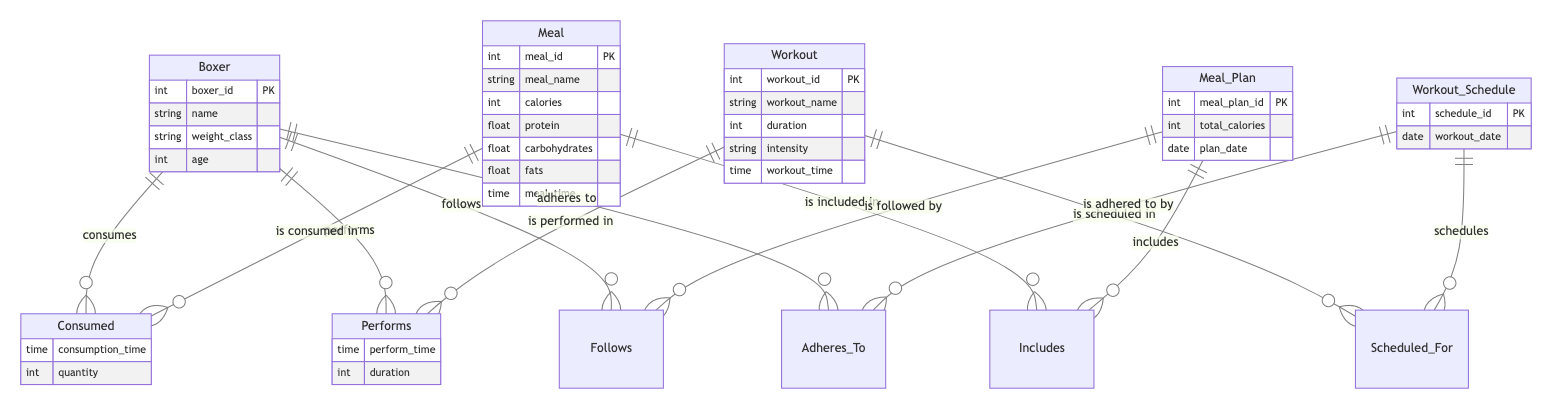What are the attributes of the Boxer entity? The Boxer entity includes the following attributes: boxer_id, name, weight_class, and age. These can be directly extracted from the entity's definition in the diagram.
Answer: boxer_id, name, weight_class, age How many attributes does the Meal entity have? The Meal entity has six attributes: meal_id, meal_name, calories, protein, carbohydrates, fats, and meal_time. Counting these attributes gives us the total.
Answer: 6 What relationship connects Boxer and Meal? The relationship that connects Boxer and Meal is called "Consumed." It indicates that a boxer consumes meals, which is clearly labeled in the diagram.
Answer: Consumed What is the cardinality of the relationship between Meal_Plan and Meal? The cardinality is many-to-many, as a meal plan can include multiple meals, and a meal can be part of multiple meal plans, as indicated by the diagram connections.
Answer: many-to-many What does the relationship "Scheduled_For" imply about Workout_Schedule and Workout? "Scheduled_For" indicates that a workout schedule includes one or more workouts scheduled on specific dates, clearly represented in the relationship in the diagram.
Answer: includes workouts Which entity is associated with the attribute "perform_time"? The attribute "perform_time" is associated with the "Performs" relationship, which connects the Boxer entity to the Workout entity. It specifies when the boxer performs a workout.
Answer: Performs How many meal attributes are there related to calories? There is one meal attribute specifically related to calories, which is the "calories" attribute in the Meal entity. Thus, the count is straightforward based on the entity details.
Answer: 1 Which two entities are linked by the "Adheres_To" relationship? The "Adheres_To" relationship connects the Boxer entity and the Workout_Schedule entity, indicating that a boxer adheres to a certain workout schedule.
Answer: Boxer and Workout_Schedule What is shared between the Workout and Meal entities? Both the Workout and Meal entities share a relationship with the Boxer entity, but they are not directly linked to each other. The relationships represent how each is related to the boxer.
Answer: Boxer 